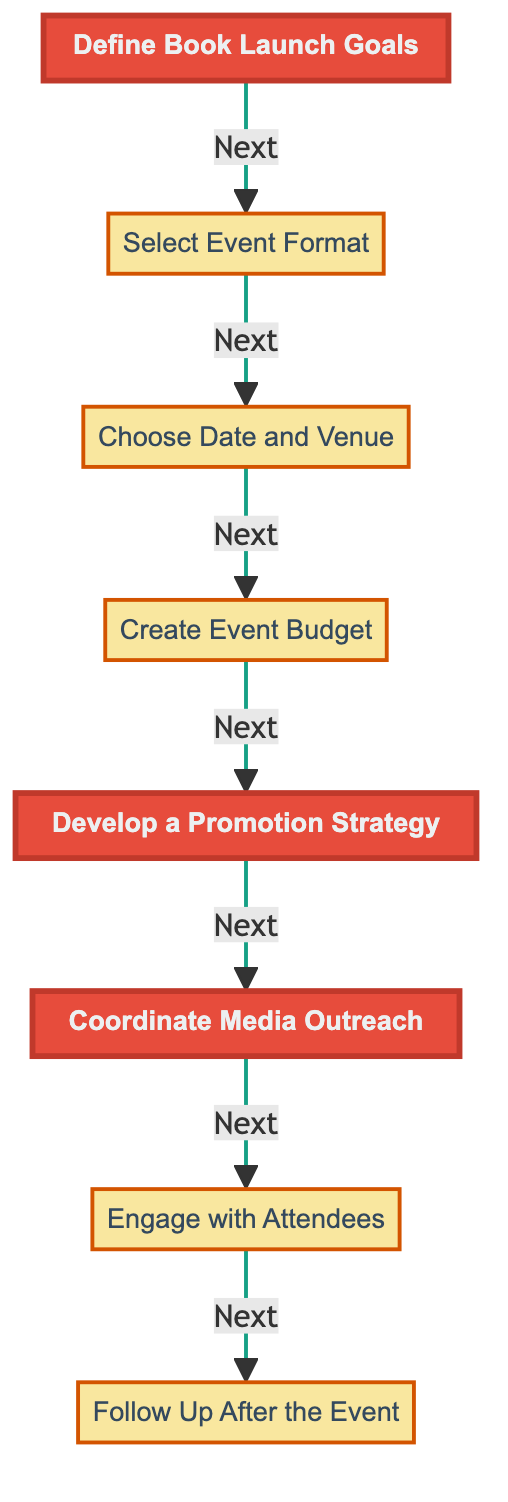What is the first step in the flow chart? The flow chart starts with the step labeled "Define Book Launch Goals," as indicated at the top.
Answer: Define Book Launch Goals How many total steps are there in the diagram? Counting each node from the flow chart shows there are eight steps, starting from "Define Book Launch Goals" to "Follow Up After the Event."
Answer: 8 What comes after "Create Event Budget"? Following the flow from the diagram, the step that comes after "Create Event Budget" is "Develop a Promotion Strategy."
Answer: Develop a Promotion Strategy Which steps are highlighted in the diagram? The highlighted steps as indicated are "Define Book Launch Goals," "Develop a Promotion Strategy," and "Coordinate Media Outreach."
Answer: Define Book Launch Goals, Develop a Promotion Strategy, Coordinate Media Outreach What is the relationship between "Select Event Format" and "Choose Date and Venue"? In the flow chart, "Select Event Format" directly leads to "Choose Date and Venue," showing a sequential process where choosing the format comes before selecting the date and venue.
Answer: Sequential relationship What is the last action to be taken as per the flow chart? The final action in the flow chart is "Follow Up After the Event," which is the last step in the sequence.
Answer: Follow Up After the Event Which node describes the expenses related to the event? The node that outlines the expenses is "Create Event Budget," which details expenses for venue, catering, decorations, and promotional materials.
Answer: Create Event Budget What type of engagement does the flow chart suggest with attendees? The diagram suggests planning interactive elements to involve guests, such as Q&A sessions or signing activities, which is outlined in the step "Engage with Attendees."
Answer: Interactive elements 